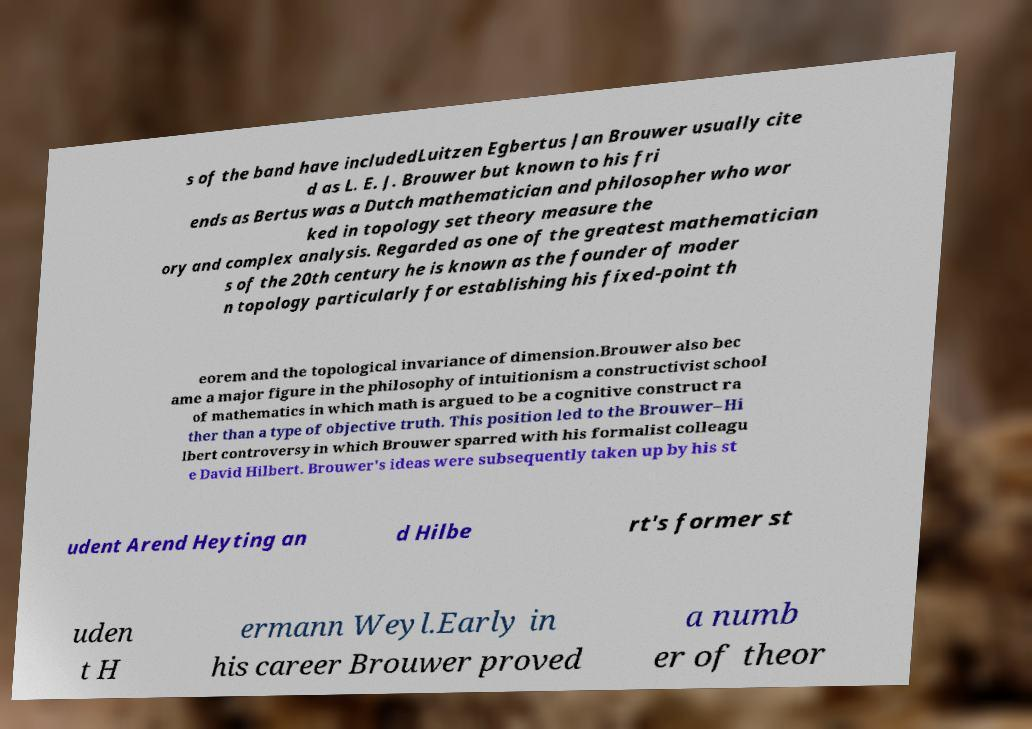What messages or text are displayed in this image? I need them in a readable, typed format. s of the band have includedLuitzen Egbertus Jan Brouwer usually cite d as L. E. J. Brouwer but known to his fri ends as Bertus was a Dutch mathematician and philosopher who wor ked in topology set theory measure the ory and complex analysis. Regarded as one of the greatest mathematician s of the 20th century he is known as the founder of moder n topology particularly for establishing his fixed-point th eorem and the topological invariance of dimension.Brouwer also bec ame a major figure in the philosophy of intuitionism a constructivist school of mathematics in which math is argued to be a cognitive construct ra ther than a type of objective truth. This position led to the Brouwer–Hi lbert controversy in which Brouwer sparred with his formalist colleagu e David Hilbert. Brouwer's ideas were subsequently taken up by his st udent Arend Heyting an d Hilbe rt's former st uden t H ermann Weyl.Early in his career Brouwer proved a numb er of theor 